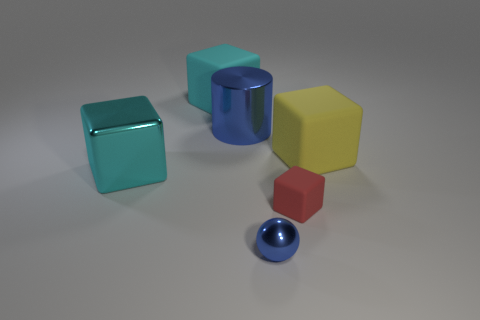Subtract all gray cylinders. Subtract all green spheres. How many cylinders are left? 1 Subtract all red cylinders. How many cyan spheres are left? 0 Add 2 tiny things. How many cyans exist? 0 Subtract all small brown metallic spheres. Subtract all cyan things. How many objects are left? 4 Add 5 balls. How many balls are left? 6 Add 5 brown metallic blocks. How many brown metallic blocks exist? 5 Add 4 spheres. How many objects exist? 10 Subtract all cyan blocks. How many blocks are left? 2 Subtract all big cyan metallic cubes. How many cubes are left? 3 Subtract 0 red balls. How many objects are left? 6 